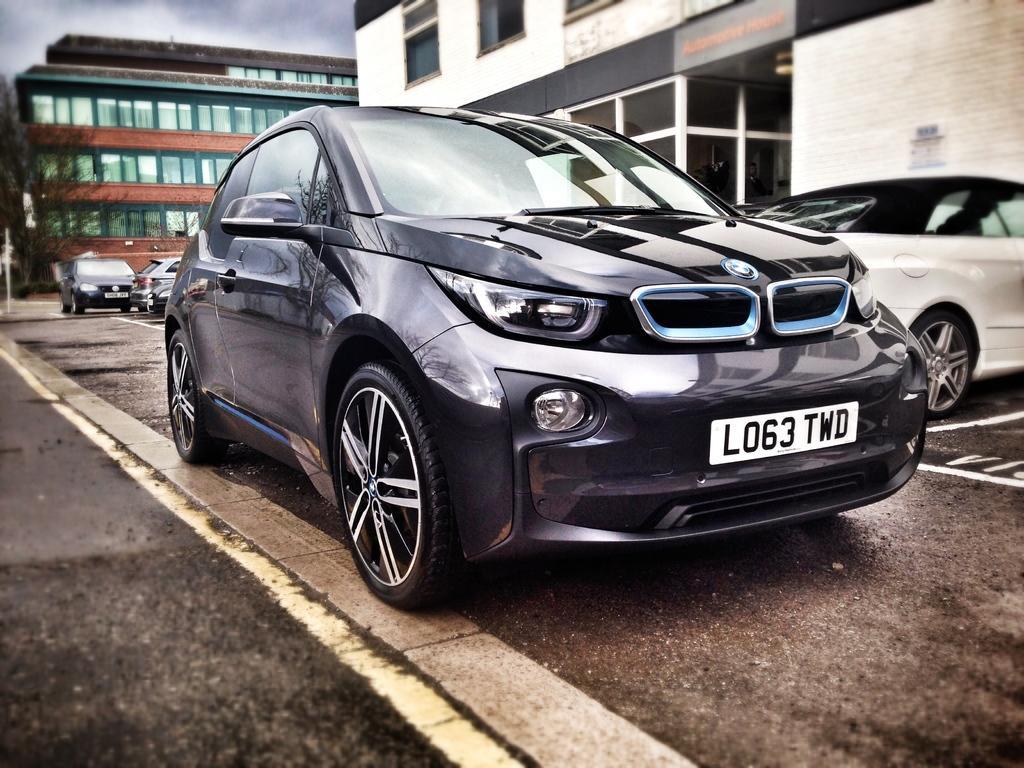Can you describe this image briefly? In this image we can see these cars are moving on the road and these cars are parked here. In the background, we can see buildings and the cloudy sky. This part of the image is slightly blurred. 